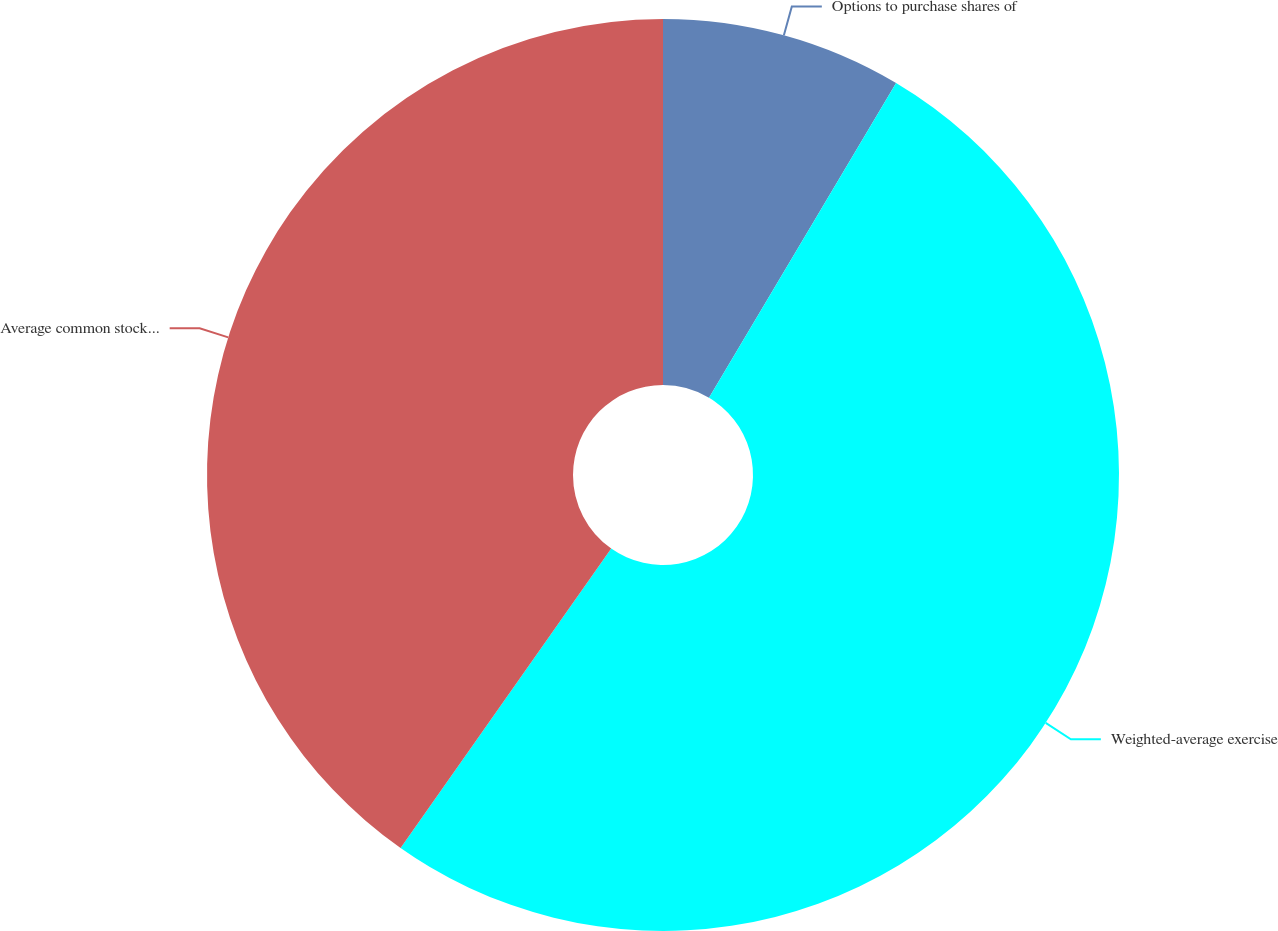Convert chart. <chart><loc_0><loc_0><loc_500><loc_500><pie_chart><fcel>Options to purchase shares of<fcel>Weighted-average exercise<fcel>Average common stock price<nl><fcel>8.54%<fcel>51.22%<fcel>40.24%<nl></chart> 